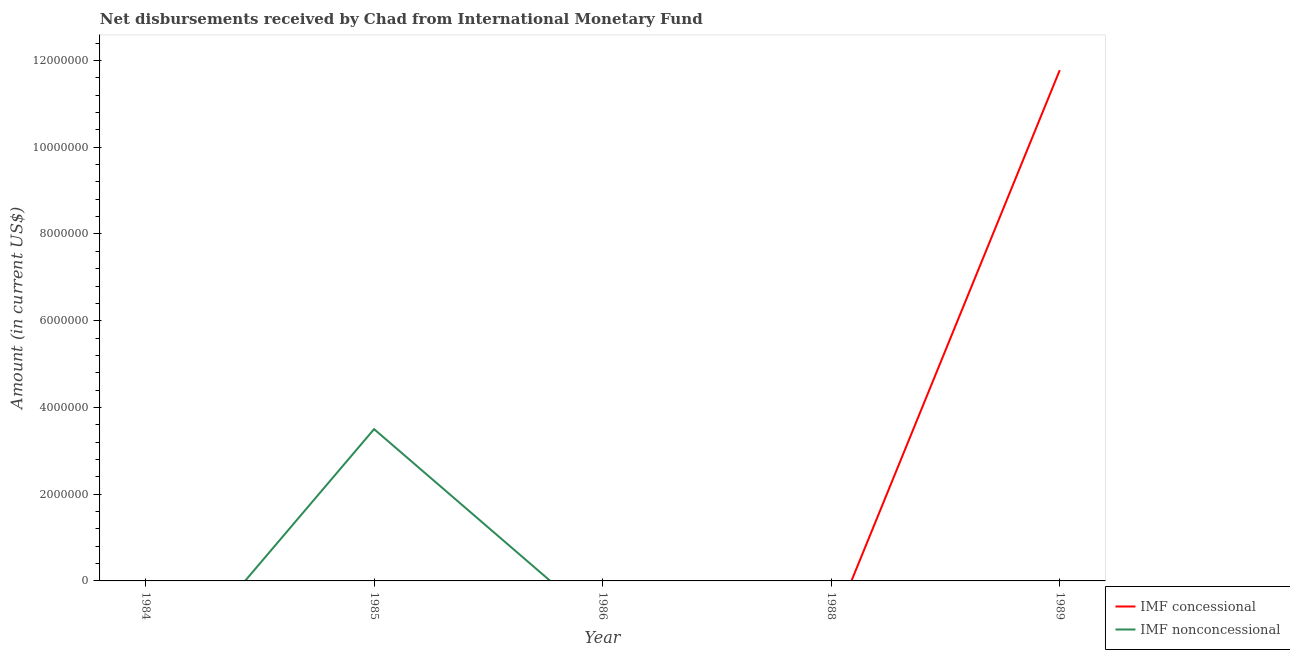Does the line corresponding to net concessional disbursements from imf intersect with the line corresponding to net non concessional disbursements from imf?
Provide a succinct answer. Yes. Is the number of lines equal to the number of legend labels?
Provide a succinct answer. No. What is the net non concessional disbursements from imf in 1986?
Keep it short and to the point. 0. Across all years, what is the maximum net non concessional disbursements from imf?
Offer a terse response. 3.50e+06. Across all years, what is the minimum net concessional disbursements from imf?
Ensure brevity in your answer.  0. In which year was the net non concessional disbursements from imf maximum?
Give a very brief answer. 1985. What is the total net concessional disbursements from imf in the graph?
Provide a short and direct response. 1.18e+07. What is the average net concessional disbursements from imf per year?
Keep it short and to the point. 2.36e+06. In how many years, is the net concessional disbursements from imf greater than 3200000 US$?
Keep it short and to the point. 1. What is the difference between the highest and the lowest net concessional disbursements from imf?
Your response must be concise. 1.18e+07. How many lines are there?
Your response must be concise. 2. How many years are there in the graph?
Offer a terse response. 5. Does the graph contain any zero values?
Offer a very short reply. Yes. Does the graph contain grids?
Keep it short and to the point. No. How many legend labels are there?
Keep it short and to the point. 2. What is the title of the graph?
Keep it short and to the point. Net disbursements received by Chad from International Monetary Fund. What is the Amount (in current US$) in IMF nonconcessional in 1984?
Offer a terse response. 0. What is the Amount (in current US$) in IMF concessional in 1985?
Ensure brevity in your answer.  0. What is the Amount (in current US$) of IMF nonconcessional in 1985?
Your answer should be compact. 3.50e+06. What is the Amount (in current US$) of IMF concessional in 1989?
Your answer should be very brief. 1.18e+07. Across all years, what is the maximum Amount (in current US$) of IMF concessional?
Keep it short and to the point. 1.18e+07. Across all years, what is the maximum Amount (in current US$) of IMF nonconcessional?
Give a very brief answer. 3.50e+06. Across all years, what is the minimum Amount (in current US$) of IMF concessional?
Make the answer very short. 0. What is the total Amount (in current US$) of IMF concessional in the graph?
Ensure brevity in your answer.  1.18e+07. What is the total Amount (in current US$) of IMF nonconcessional in the graph?
Provide a short and direct response. 3.50e+06. What is the average Amount (in current US$) of IMF concessional per year?
Provide a succinct answer. 2.36e+06. What is the average Amount (in current US$) of IMF nonconcessional per year?
Make the answer very short. 7.00e+05. What is the difference between the highest and the lowest Amount (in current US$) in IMF concessional?
Make the answer very short. 1.18e+07. What is the difference between the highest and the lowest Amount (in current US$) in IMF nonconcessional?
Give a very brief answer. 3.50e+06. 